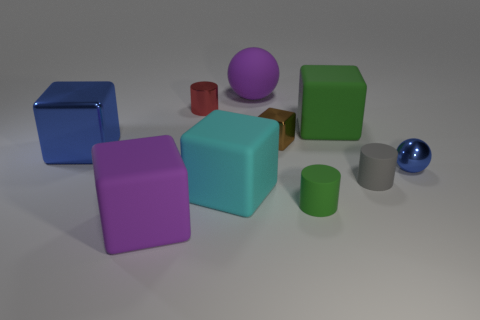Does the big purple sphere have the same material as the purple object that is in front of the green matte block?
Keep it short and to the point. Yes. There is a blue metal object that is right of the purple cube; does it have the same shape as the cyan matte object?
Your answer should be very brief. No. What material is the small brown object that is the same shape as the big blue metal object?
Provide a short and direct response. Metal. There is a large green rubber object; is it the same shape as the purple rubber object that is in front of the gray thing?
Your response must be concise. Yes. There is a block that is both in front of the big green matte thing and right of the purple rubber ball; what color is it?
Ensure brevity in your answer.  Brown. Are there any small gray rubber things?
Keep it short and to the point. Yes. Are there the same number of metallic things on the right side of the small green matte cylinder and tiny gray objects?
Give a very brief answer. Yes. How many other objects are there of the same shape as the big cyan thing?
Keep it short and to the point. 4. The brown object has what shape?
Give a very brief answer. Cube. Is the material of the big blue thing the same as the tiny blue object?
Make the answer very short. Yes. 